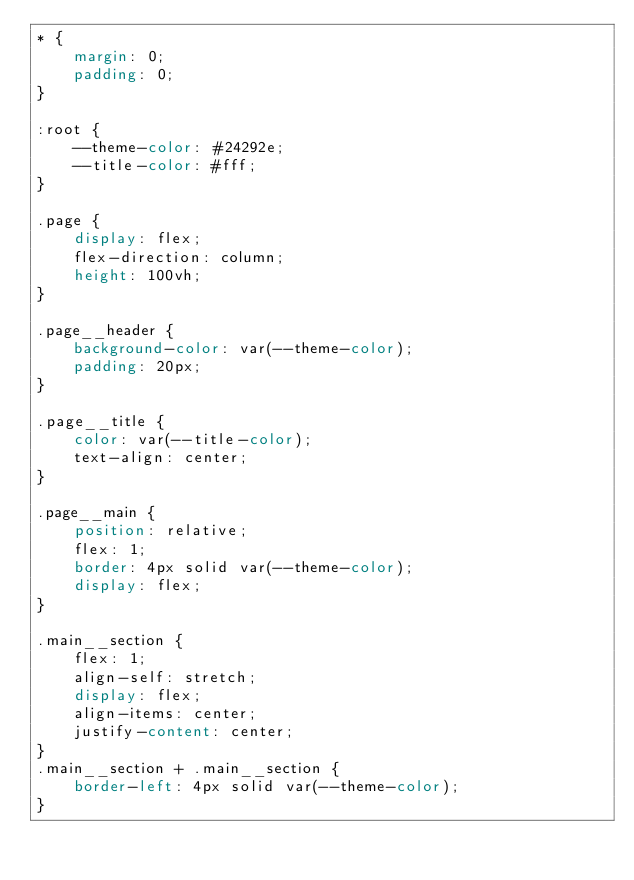<code> <loc_0><loc_0><loc_500><loc_500><_CSS_>* {
	margin: 0;
	padding: 0;
}

:root {
	--theme-color: #24292e;
	--title-color: #fff;
}

.page {
	display: flex;
	flex-direction: column;
	height: 100vh;
}

.page__header {
	background-color: var(--theme-color);
	padding: 20px;
}

.page__title {
	color: var(--title-color);
	text-align: center;
}

.page__main {
	position: relative;
	flex: 1;
	border: 4px solid var(--theme-color);
	display: flex;
}

.main__section {
	flex: 1;
	align-self: stretch;
	display: flex;
	align-items: center;
	justify-content: center;
}
.main__section + .main__section {
	border-left: 4px solid var(--theme-color);
}</code> 